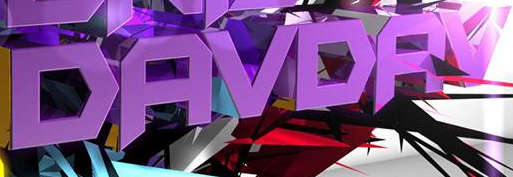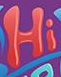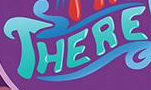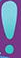Identify the words shown in these images in order, separated by a semicolon. DAVDAV; Hi; THERE; ! 